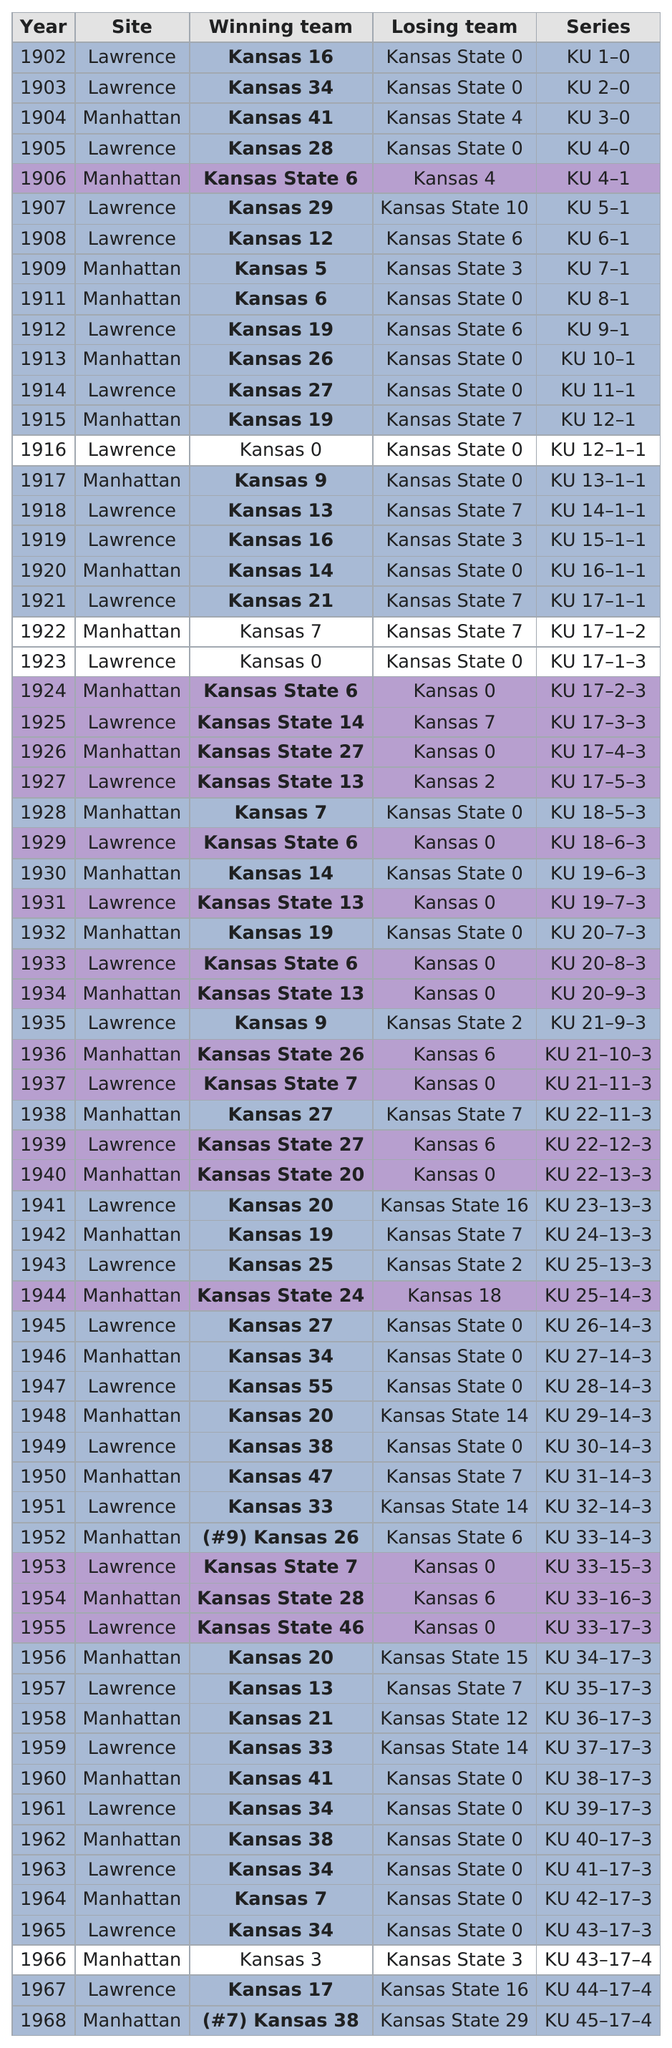Mention a couple of crucial points in this snapshot. In the period of 1902-1968, Kansas State failed to score a single point against Kansas a total of 23 times. Between 1902 and 1968, Kansas and Kansas State played football in Lawrence a total of 34 times. In total, 66 games have been played. Kansas State had a total of eight wins during their games played in Manhattan. On January 1st, 1926, Kansas State won its first game by double digits. 